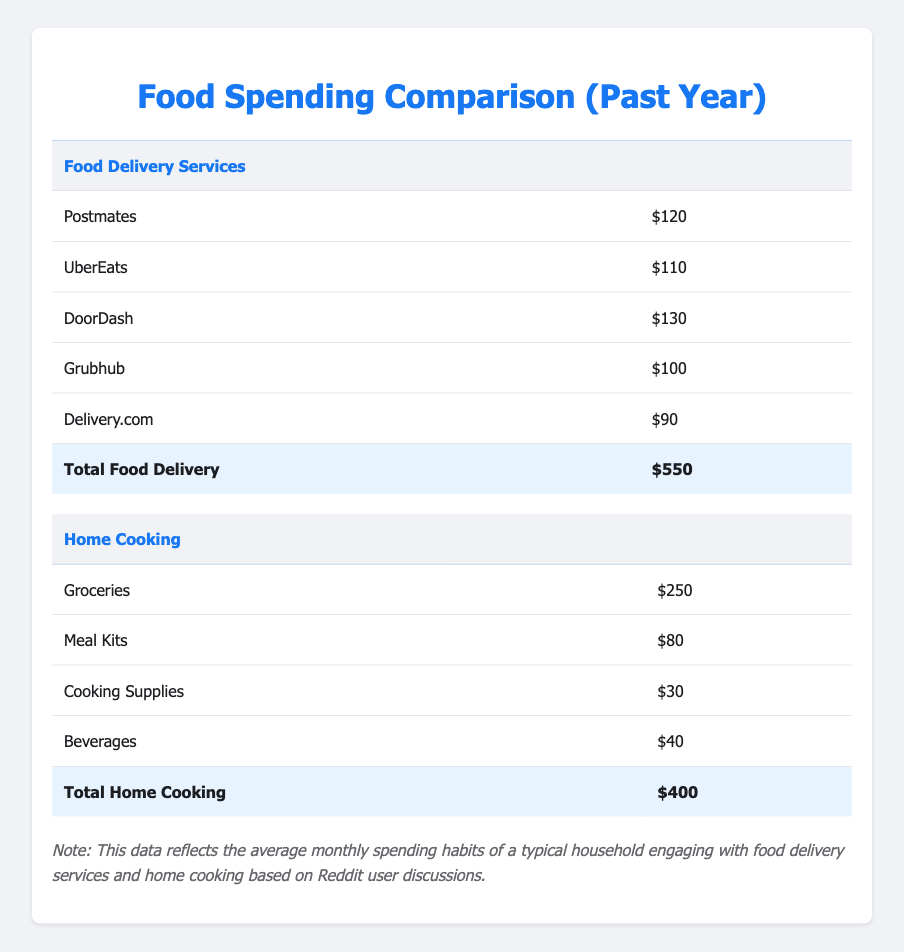What is the average monthly spending on DoorDash? The table lists that the average monthly spending on DoorDash is $130.
Answer: 130 Which food delivery service has the highest average monthly spending? The table shows that DoorDash has the highest average monthly spending at $130.
Answer: DoorDash What is the total average monthly spending on food delivery services? The total average monthly spending on food delivery services is shown in the table as $550.
Answer: 550 What is the difference between the total average monthly spending on food delivery services and home cooking? The total for food delivery is $550, and the total for home cooking is $400. The difference is $550 - $400 = $150.
Answer: 150 Is the average monthly spending on groceries higher than on meal kits? The average monthly spending on groceries is $250 and on meal kits is $80. Since $250 is higher than $80, the answer is yes.
Answer: Yes Which category of spending is greater, food delivery services or home cooking? The total for food delivery services is $550, while home cooking is $400. Since $550 is greater than $400, food delivery services have a greater total spending.
Answer: Food delivery services If a household spends $150 on groceries, how much more or less do they spend compared to beverages? Beverages cost $40, and the household spends $150 on groceries. The calculation is $150 - $40 = $110, meaning they spend $110 more on groceries.
Answer: 110 more What is the average monthly spending on home cooking (Groceries, Meal Kits, Cooking Supplies, Beverages)? The average spending is calculated by summing these amounts: $250 (Groceries) + $80 (Meal Kits) + $30 (Cooking Supplies) + $40 (Beverages) = $400. Then dividing by 4 categories gives an average of $100.
Answer: 100 True or False: The average total spending on food delivery services is lower than that of home cooking. The total spending on food delivery services is $550, and on home cooking, it is $400. Since $550 is greater than $400, this statement is false.
Answer: False 